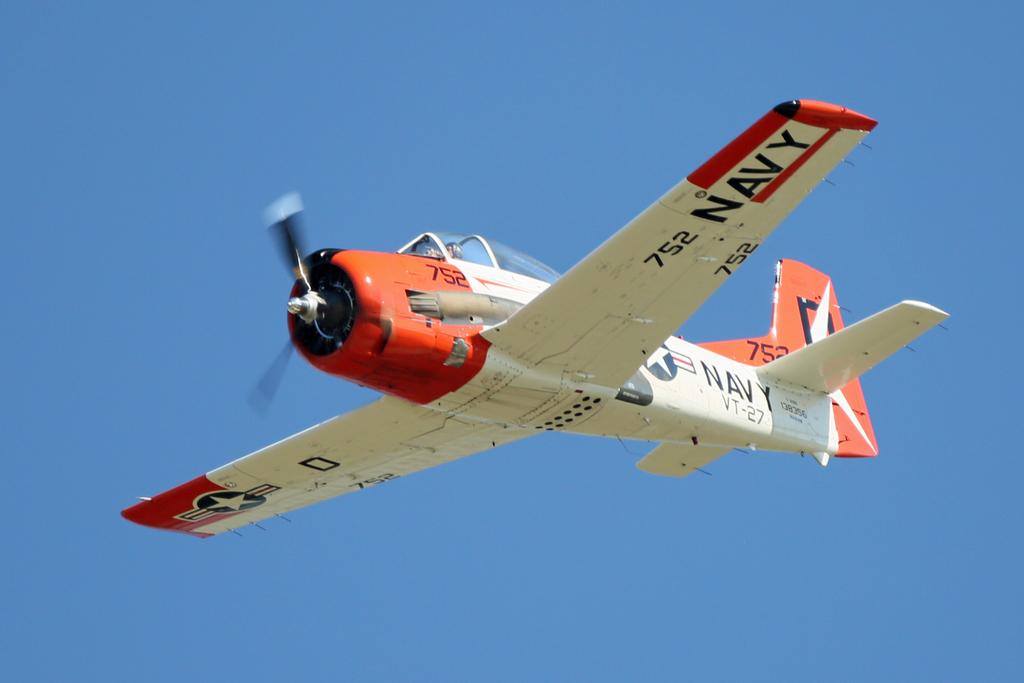What branch of the military does this plane belong to?
Provide a short and direct response. Navy. What's the plane's number?
Ensure brevity in your answer.  752. 